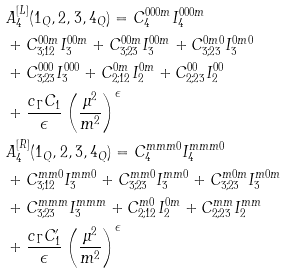Convert formula to latex. <formula><loc_0><loc_0><loc_500><loc_500>& A ^ { [ L ] } _ { 4 } ( 1 _ { Q } , 2 , 3 , 4 _ { Q } ) = C _ { 4 } ^ { 0 0 0 m } I _ { 4 } ^ { 0 0 0 m } \\ & + C _ { 3 ; 1 2 } ^ { 0 0 m } I _ { 3 } ^ { 0 0 m } + C _ { 3 ; 2 3 } ^ { 0 0 m } I _ { 3 } ^ { 0 0 m } + C _ { 3 ; 2 3 } ^ { 0 m 0 } I _ { 3 } ^ { 0 m 0 } \\ & + C _ { 3 ; 2 3 } ^ { 0 0 0 } I _ { 3 } ^ { 0 0 0 } + C _ { 2 ; 1 2 } ^ { 0 m } I _ { 2 } ^ { 0 m } + C _ { 2 ; 2 3 } ^ { 0 0 } I _ { 2 } ^ { 0 0 } \\ & + \frac { c _ { \Gamma } C _ { 1 } } { \epsilon } \left ( \frac { \mu ^ { 2 } } { m ^ { 2 } } \right ) ^ { \epsilon } \\ & A ^ { [ R ] } _ { 4 } ( 1 _ { Q } , 2 , 3 , 4 _ { Q } ) = C _ { 4 } ^ { m m m 0 } I _ { 4 } ^ { m m m 0 } \\ & + C _ { 3 ; 1 2 } ^ { m m 0 } I _ { 3 } ^ { m m 0 } + C _ { 3 ; 2 3 } ^ { m m 0 } I _ { 3 } ^ { m m 0 } + C _ { 3 ; 2 3 } ^ { m 0 m } I _ { 3 } ^ { m 0 m } \\ & + C _ { 3 ; 2 3 } ^ { m m m } I _ { 3 } ^ { m m m } + C _ { 2 ; 1 2 } ^ { m 0 } I _ { 2 } ^ { 0 m } + C _ { 2 ; 2 3 } ^ { m m } I _ { 2 } ^ { m m } \\ & + \frac { c _ { \Gamma } C _ { 1 } ^ { \prime } } { \epsilon } \left ( \frac { \mu ^ { 2 } } { m ^ { 2 } } \right ) ^ { \epsilon }</formula> 